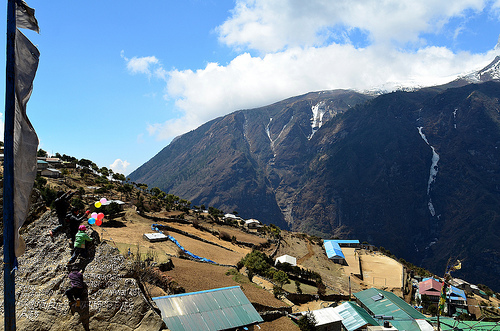<image>
Can you confirm if the mountain is on the cloud? No. The mountain is not positioned on the cloud. They may be near each other, but the mountain is not supported by or resting on top of the cloud. Where is the balloon in relation to the house? Is it on the house? No. The balloon is not positioned on the house. They may be near each other, but the balloon is not supported by or resting on top of the house. 